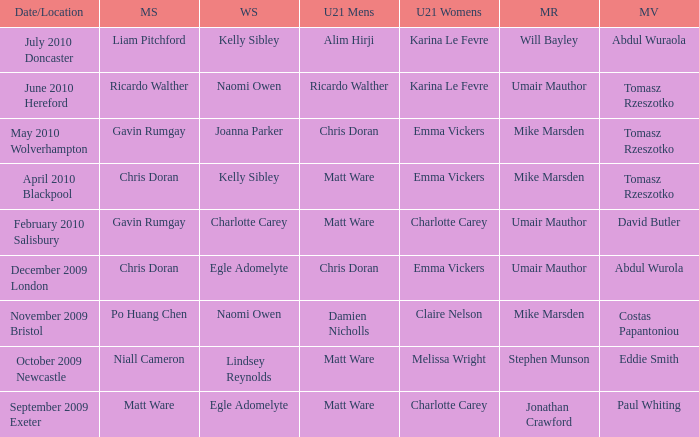When Matt Ware won the mens singles, who won the mixed restricted? Jonathan Crawford. 